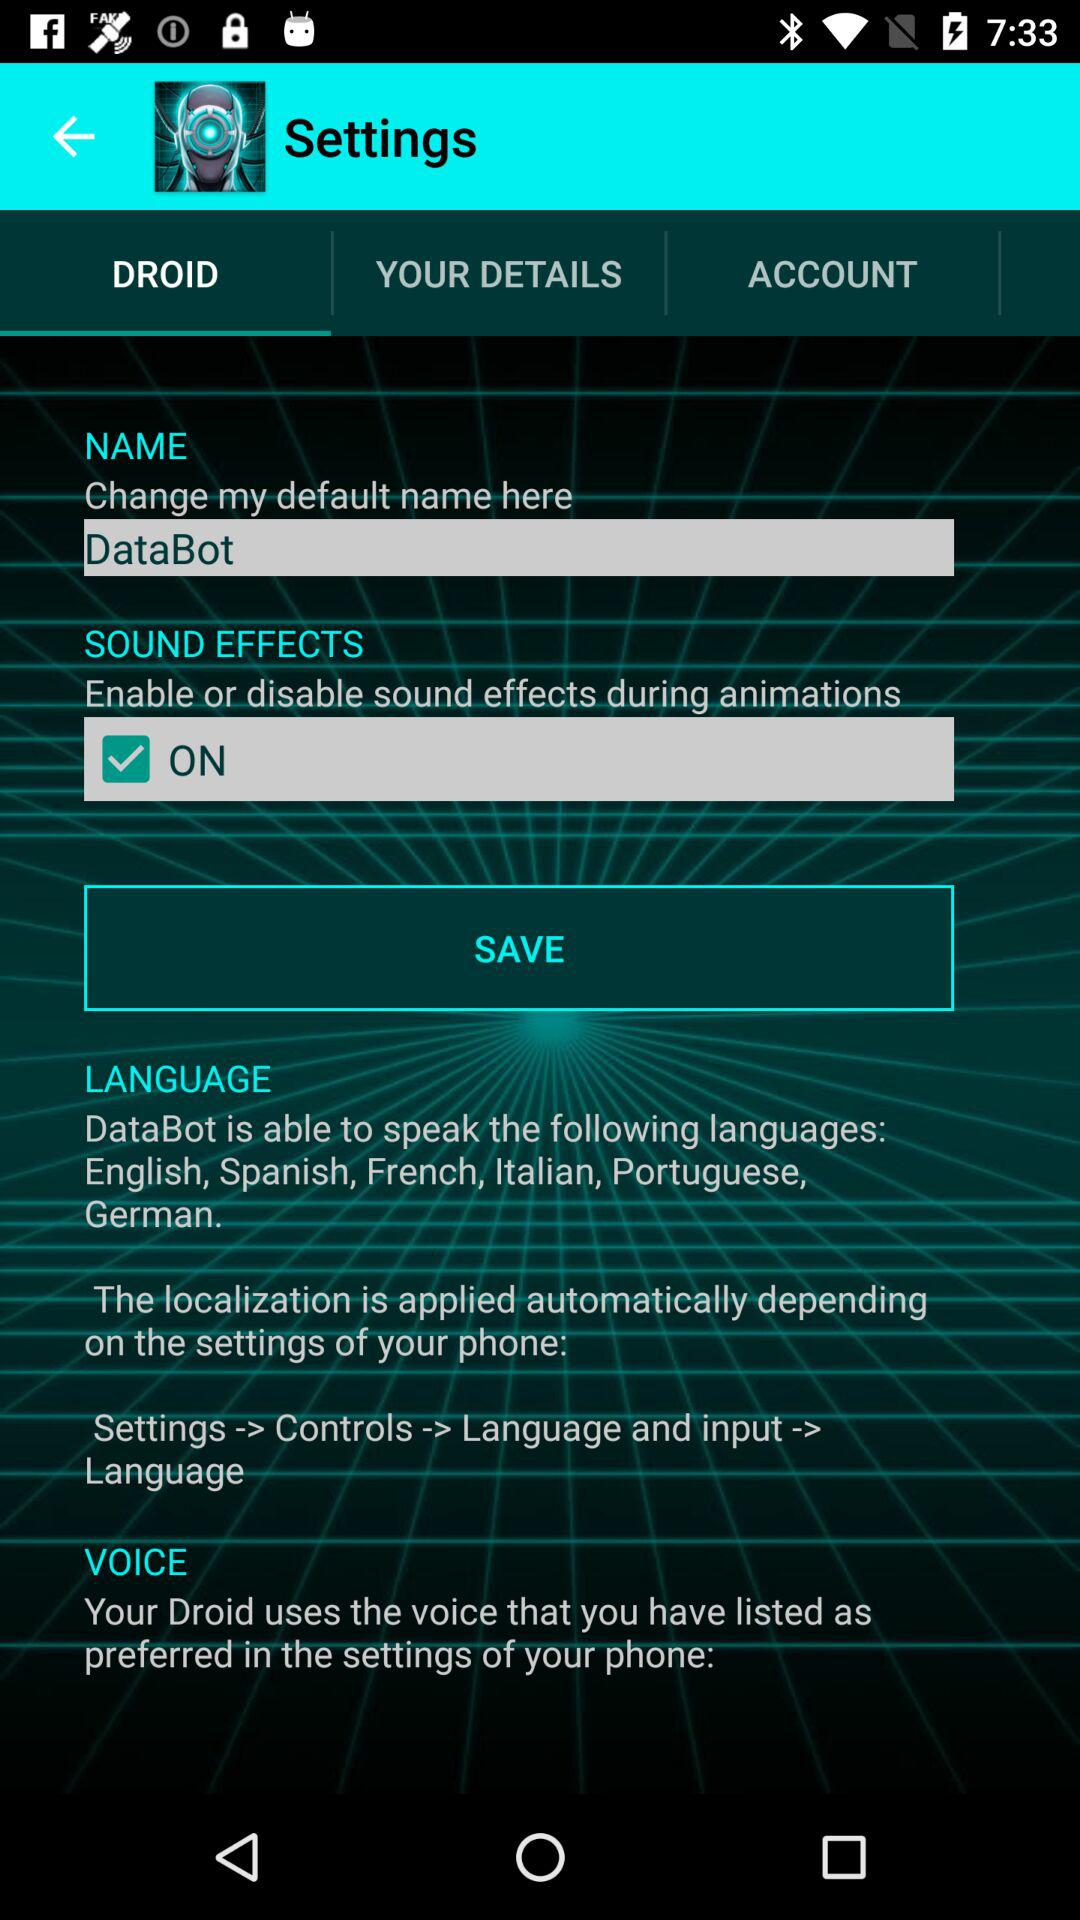Which tab is selected? The selected tab is "DROID". 